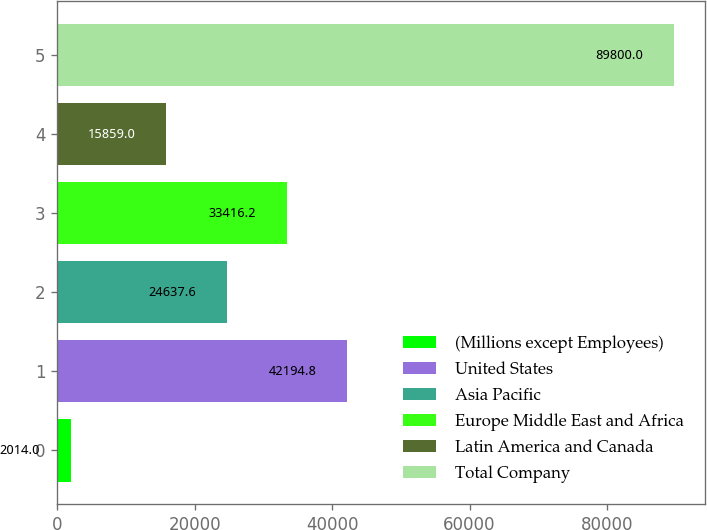Convert chart to OTSL. <chart><loc_0><loc_0><loc_500><loc_500><bar_chart><fcel>(Millions except Employees)<fcel>United States<fcel>Asia Pacific<fcel>Europe Middle East and Africa<fcel>Latin America and Canada<fcel>Total Company<nl><fcel>2014<fcel>42194.8<fcel>24637.6<fcel>33416.2<fcel>15859<fcel>89800<nl></chart> 